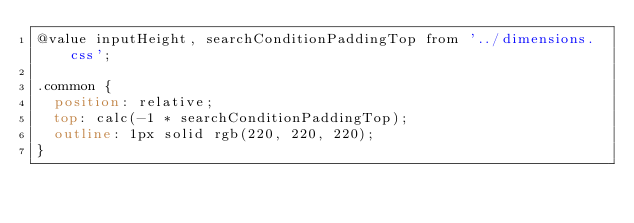Convert code to text. <code><loc_0><loc_0><loc_500><loc_500><_CSS_>@value inputHeight, searchConditionPaddingTop from '../dimensions.css';

.common {
  position: relative;
  top: calc(-1 * searchConditionPaddingTop);
  outline: 1px solid rgb(220, 220, 220);
}
</code> 